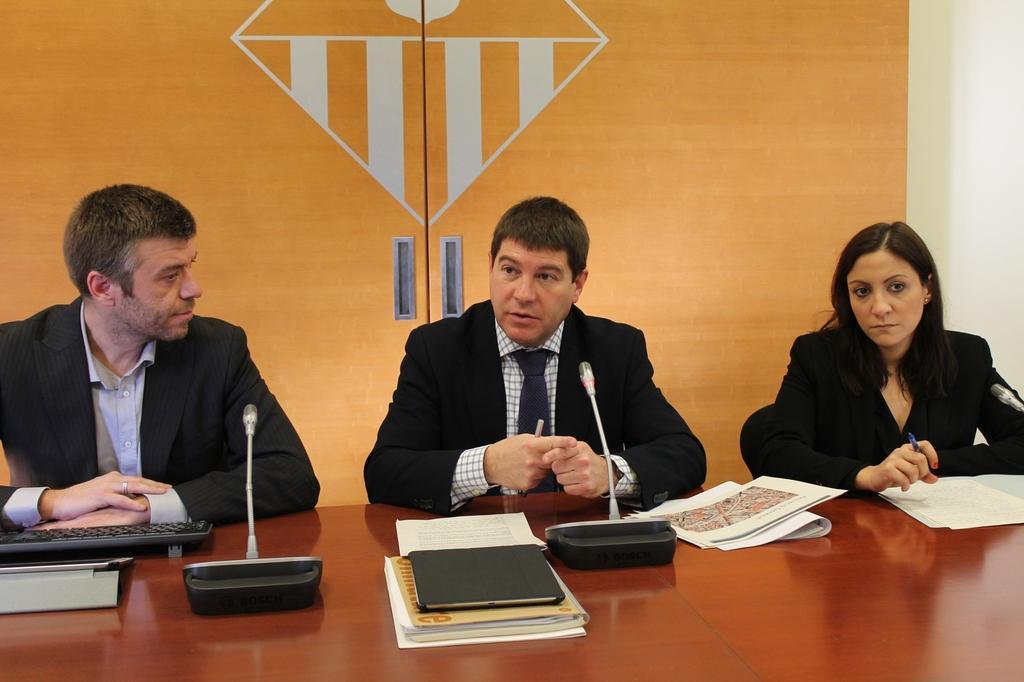Could you give a brief overview of what you see in this image? In this image I can see there are three persons sitting in front of the table, on the table I can see mike, keypad and books, papers kept and I can see a wooden door visible at the background. 